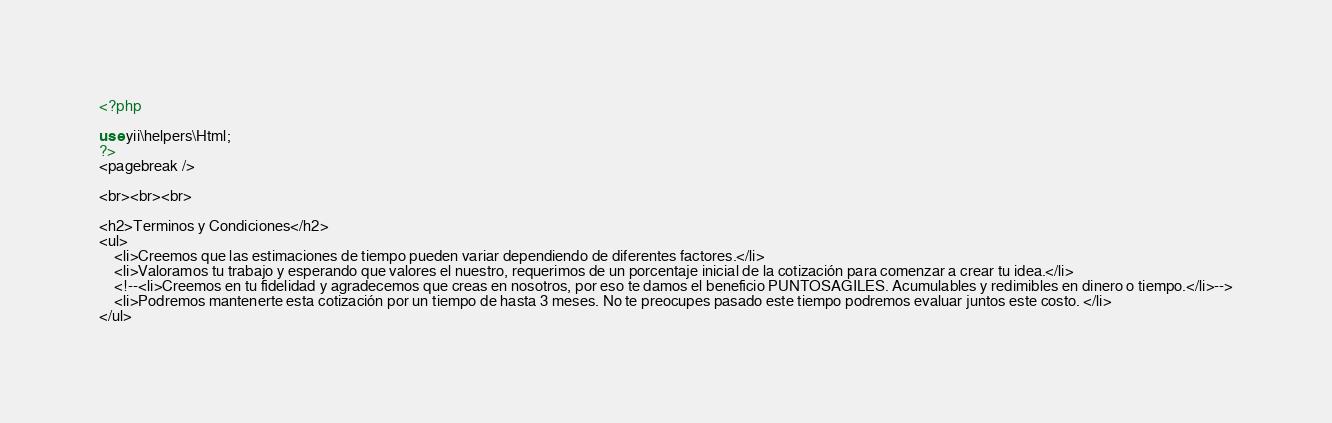Convert code to text. <code><loc_0><loc_0><loc_500><loc_500><_PHP_><?php

use yii\helpers\Html;
?>
<pagebreak />

<br><br><br>

<h2>Terminos y Condiciones</h2>
<ul>
    <li>Creemos que las estimaciones de tiempo pueden variar dependiendo de diferentes factores.</li>
    <li>Valoramos tu trabajo y esperando que valores el nuestro, requerimos de un porcentaje inicial de la cotización para comenzar a crear tu idea.</li>
    <!--<li>Creemos en tu fidelidad y agradecemos que creas en nosotros, por eso te damos el beneficio PUNTOSAGILES. Acumulables y redimibles en dinero o tiempo.</li>-->
    <li>Podremos mantenerte esta cotización por un tiempo de hasta 3 meses. No te preocupes pasado este tiempo podremos evaluar juntos este costo. </li>
</ul></code> 